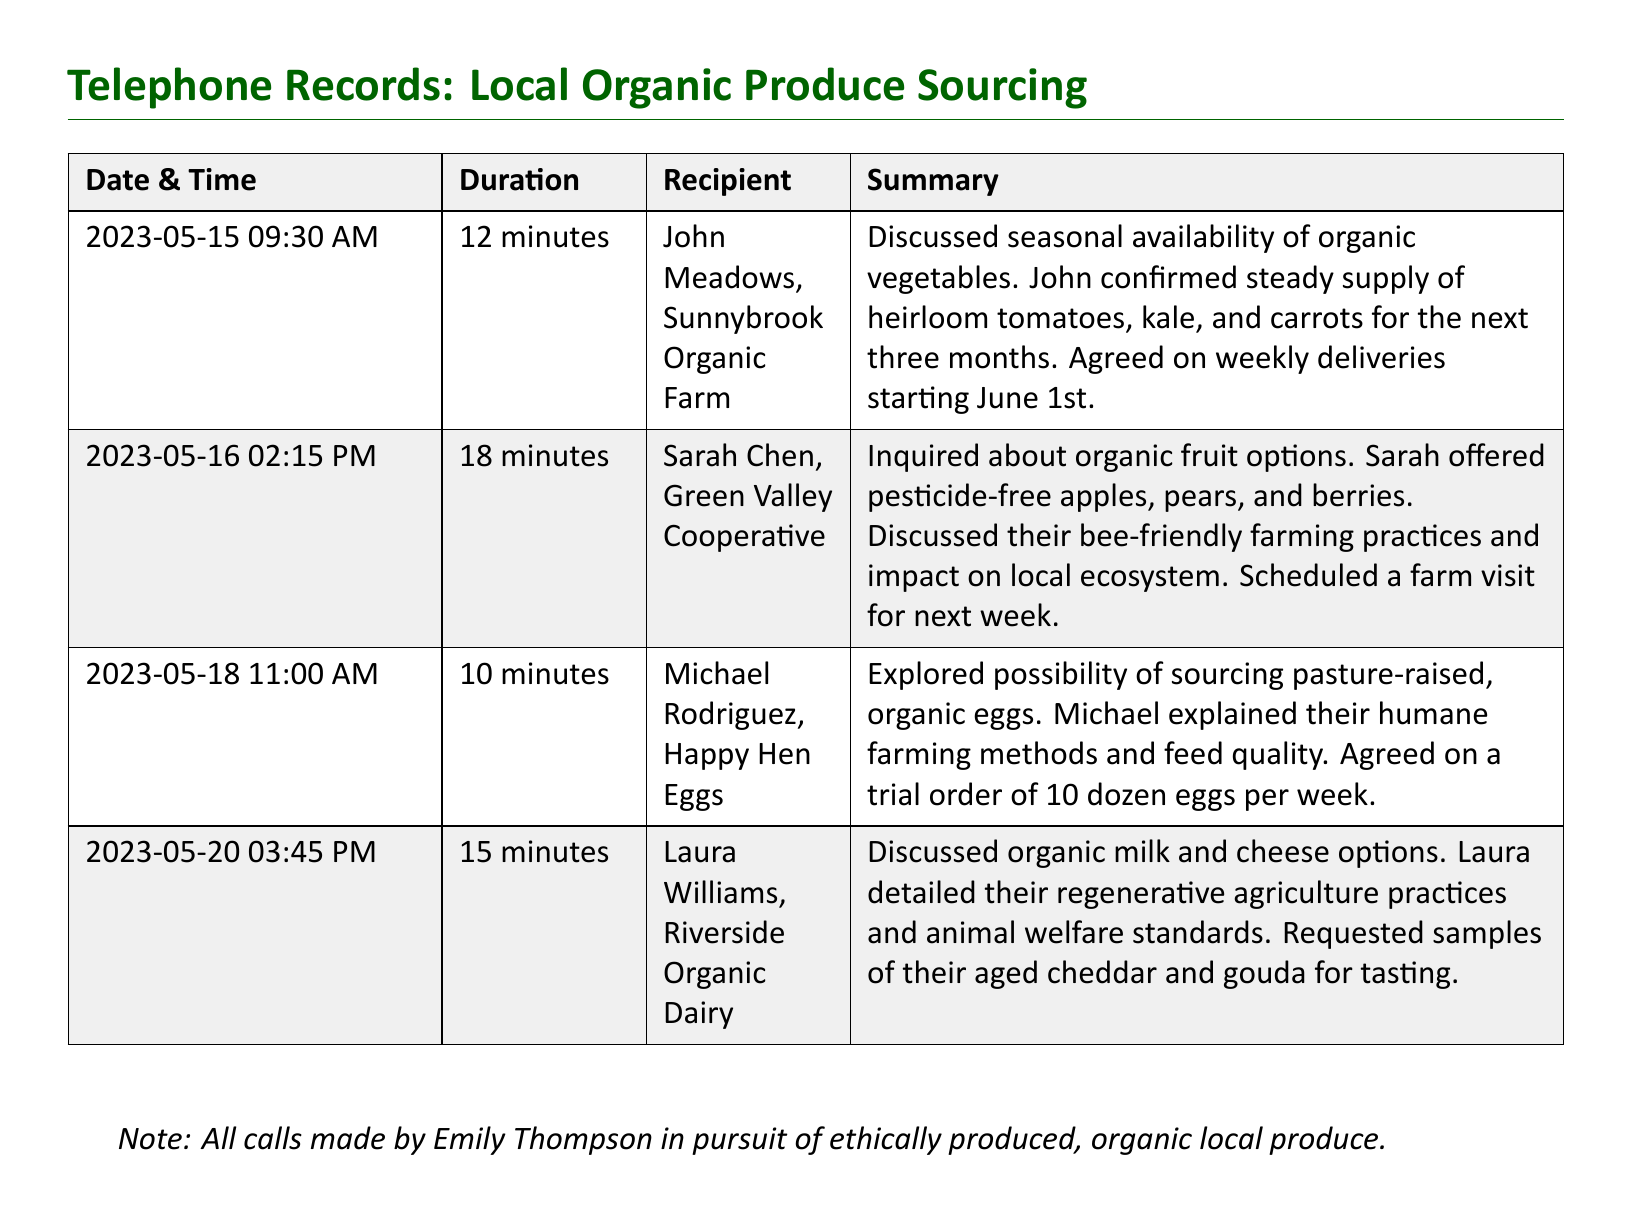What is the date of the first call? The first call in the document occurred on May 15, 2023.
Answer: May 15, 2023 Who is the recipient of the last call? The last call detailed in the document was made to Laura Williams from Riverside Organic Dairy.
Answer: Laura Williams, Riverside Organic Dairy How long was the call with Sarah Chen? The duration of the call with Sarah Chen was 18 minutes, as stated in the telephone records.
Answer: 18 minutes What type of produce is discussed for delivery starting June 1st? The discussion about heirloom tomatoes, kale, and carrots for delivery starting on June 1st is highlighted in the first call summary.
Answer: Heirloom tomatoes, kale, and carrots How many dozen eggs were agreed upon for the trial order? The document states a trial order of 10 dozen eggs per week was agreed upon with Michael Rodriguez.
Answer: 10 dozen What farming practice is highlighted by Sarah Chen? The document notes that Sarah offered details on their bee-friendly farming practices during the call.
Answer: Bee-friendly farming practices What kind of dairy products were discussed in the call with Laura? Laura Williams detailed options for organic milk and cheese during the call, as per the summary.
Answer: Organic milk and cheese What is the nature of the sourcing discussed in these calls? The calls are regarding sourcing ethically produced, organic local produce, which is emphasized in the note at the end of the document.
Answer: Ethically produced, organic local produce 